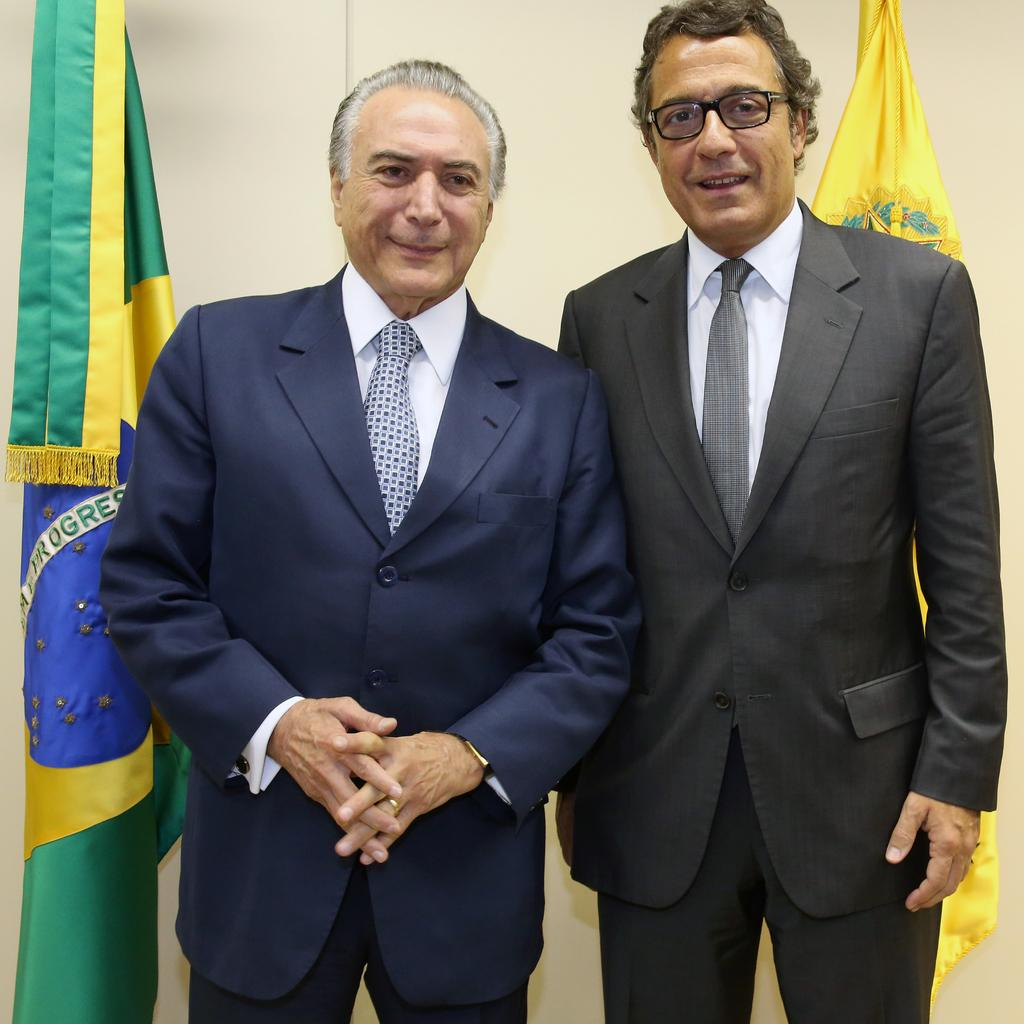How many people are in the image? There are two men in the image. What are the men wearing? The men are wearing suits. Can you describe any specific details about one of the men? One of the men is wearing spectacles. What can be seen in the background of the image? There are flags and a wall in the background of the image. What type of beef is being served at the event in the image? There is no event or beef present in the image; it features two men wearing suits and a background with flags and a wall. Can you tell me how many copies of the document are being signed by the men in the image? There is no document or signing activity present in the image; it only shows two men wearing suits and the background elements. 